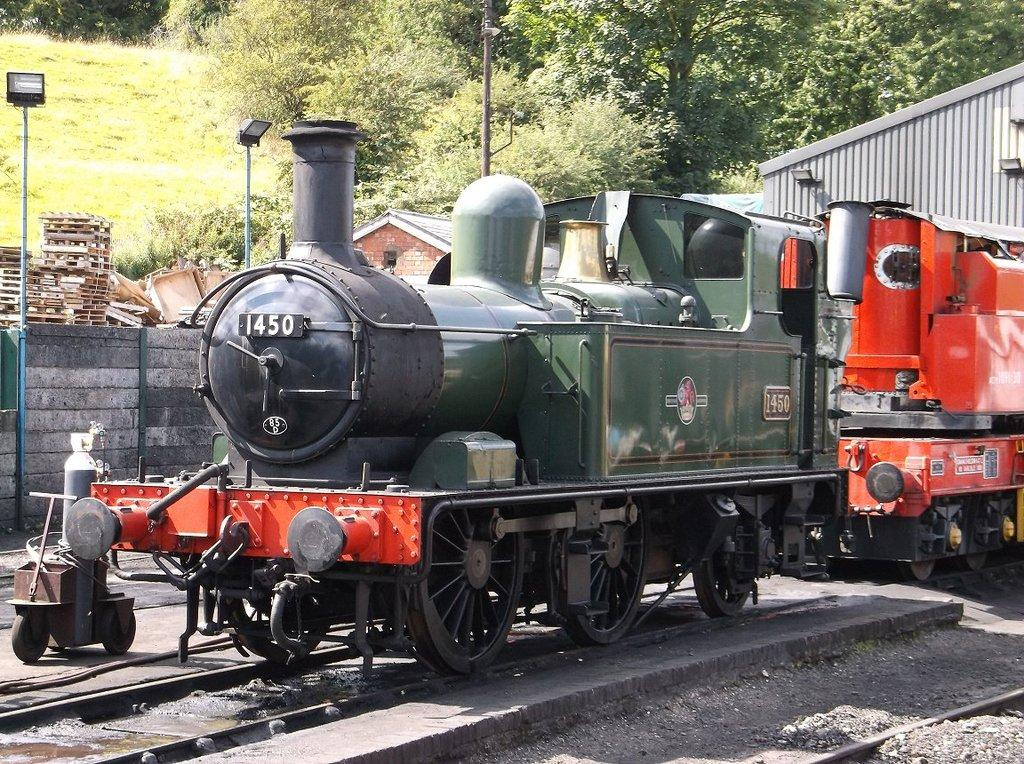<image>
Offer a succinct explanation of the picture presented. The front of a train shows it as number 1450. 